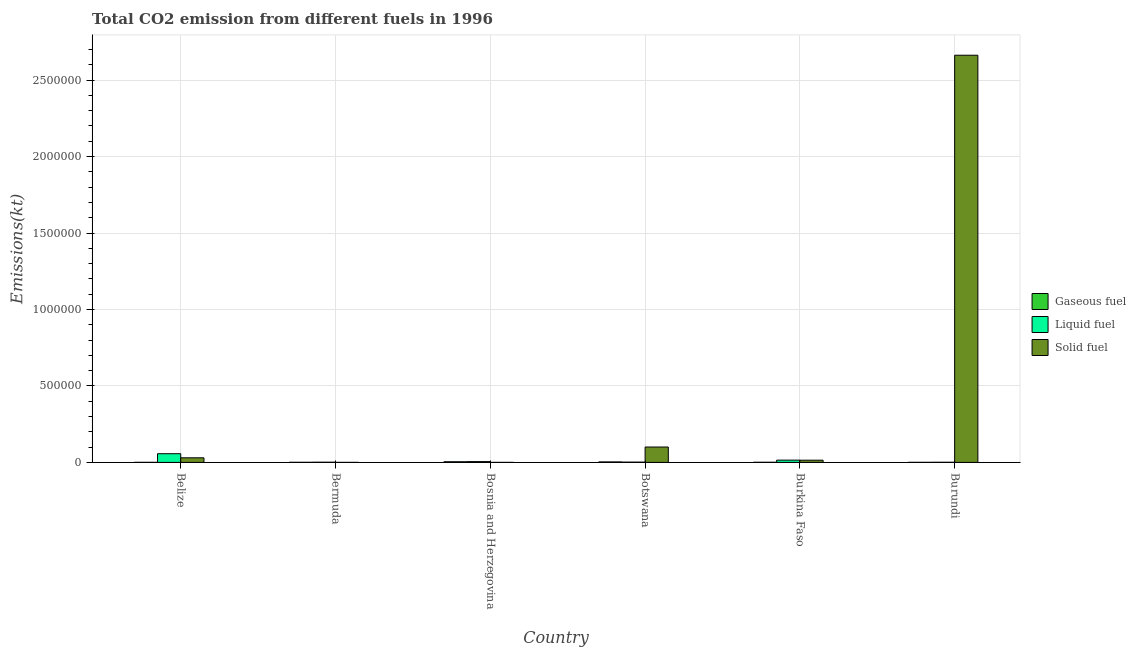How many different coloured bars are there?
Your response must be concise. 3. How many groups of bars are there?
Offer a terse response. 6. Are the number of bars per tick equal to the number of legend labels?
Ensure brevity in your answer.  Yes. Are the number of bars on each tick of the X-axis equal?
Make the answer very short. Yes. What is the label of the 1st group of bars from the left?
Your answer should be compact. Belize. What is the amount of co2 emissions from solid fuel in Belize?
Provide a short and direct response. 3.00e+04. Across all countries, what is the maximum amount of co2 emissions from gaseous fuel?
Provide a short and direct response. 4257.39. Across all countries, what is the minimum amount of co2 emissions from solid fuel?
Provide a succinct answer. 3.67. In which country was the amount of co2 emissions from liquid fuel maximum?
Offer a terse response. Belize. In which country was the amount of co2 emissions from liquid fuel minimum?
Make the answer very short. Burundi. What is the total amount of co2 emissions from liquid fuel in the graph?
Make the answer very short. 8.03e+04. What is the difference between the amount of co2 emissions from liquid fuel in Bermuda and that in Bosnia and Herzegovina?
Your answer should be compact. -4151.04. What is the difference between the amount of co2 emissions from gaseous fuel in Burkina Faso and the amount of co2 emissions from liquid fuel in Botswana?
Ensure brevity in your answer.  -1001.09. What is the average amount of co2 emissions from solid fuel per country?
Ensure brevity in your answer.  4.68e+05. What is the difference between the amount of co2 emissions from liquid fuel and amount of co2 emissions from solid fuel in Burundi?
Keep it short and to the point. -2.66e+06. What is the ratio of the amount of co2 emissions from solid fuel in Bermuda to that in Botswana?
Your response must be concise. 0. Is the amount of co2 emissions from solid fuel in Bosnia and Herzegovina less than that in Botswana?
Provide a short and direct response. Yes. Is the difference between the amount of co2 emissions from gaseous fuel in Botswana and Burkina Faso greater than the difference between the amount of co2 emissions from liquid fuel in Botswana and Burkina Faso?
Offer a terse response. Yes. What is the difference between the highest and the second highest amount of co2 emissions from solid fuel?
Make the answer very short. 2.56e+06. What is the difference between the highest and the lowest amount of co2 emissions from solid fuel?
Offer a very short reply. 2.66e+06. In how many countries, is the amount of co2 emissions from gaseous fuel greater than the average amount of co2 emissions from gaseous fuel taken over all countries?
Keep it short and to the point. 2. Is the sum of the amount of co2 emissions from gaseous fuel in Burkina Faso and Burundi greater than the maximum amount of co2 emissions from liquid fuel across all countries?
Offer a terse response. No. What does the 1st bar from the left in Burkina Faso represents?
Give a very brief answer. Gaseous fuel. What does the 3rd bar from the right in Burkina Faso represents?
Make the answer very short. Gaseous fuel. How many bars are there?
Offer a very short reply. 18. What is the difference between two consecutive major ticks on the Y-axis?
Your response must be concise. 5.00e+05. Are the values on the major ticks of Y-axis written in scientific E-notation?
Ensure brevity in your answer.  No. Does the graph contain any zero values?
Give a very brief answer. No. Does the graph contain grids?
Offer a terse response. Yes. Where does the legend appear in the graph?
Your answer should be very brief. Center right. How are the legend labels stacked?
Offer a very short reply. Vertical. What is the title of the graph?
Make the answer very short. Total CO2 emission from different fuels in 1996. Does "Tertiary" appear as one of the legend labels in the graph?
Your answer should be very brief. No. What is the label or title of the X-axis?
Offer a terse response. Country. What is the label or title of the Y-axis?
Offer a terse response. Emissions(kt). What is the Emissions(kt) of Gaseous fuel in Belize?
Your response must be concise. 308.03. What is the Emissions(kt) in Liquid fuel in Belize?
Your response must be concise. 5.68e+04. What is the Emissions(kt) in Solid fuel in Belize?
Provide a succinct answer. 3.00e+04. What is the Emissions(kt) in Gaseous fuel in Bermuda?
Keep it short and to the point. 476.71. What is the Emissions(kt) of Liquid fuel in Bermuda?
Your response must be concise. 1085.43. What is the Emissions(kt) of Solid fuel in Bermuda?
Your answer should be very brief. 18.34. What is the Emissions(kt) in Gaseous fuel in Bosnia and Herzegovina?
Your answer should be compact. 4257.39. What is the Emissions(kt) of Liquid fuel in Bosnia and Herzegovina?
Give a very brief answer. 5236.48. What is the Emissions(kt) in Solid fuel in Bosnia and Herzegovina?
Offer a terse response. 3.67. What is the Emissions(kt) in Gaseous fuel in Botswana?
Offer a very short reply. 3138.95. What is the Emissions(kt) in Liquid fuel in Botswana?
Provide a succinct answer. 1708.82. What is the Emissions(kt) in Solid fuel in Botswana?
Provide a short and direct response. 1.00e+05. What is the Emissions(kt) of Gaseous fuel in Burkina Faso?
Your answer should be compact. 707.73. What is the Emissions(kt) of Liquid fuel in Burkina Faso?
Keep it short and to the point. 1.48e+04. What is the Emissions(kt) of Solid fuel in Burkina Faso?
Make the answer very short. 1.44e+04. What is the Emissions(kt) of Gaseous fuel in Burundi?
Keep it short and to the point. 319.03. What is the Emissions(kt) in Liquid fuel in Burundi?
Ensure brevity in your answer.  693.06. What is the Emissions(kt) in Solid fuel in Burundi?
Your answer should be compact. 2.66e+06. Across all countries, what is the maximum Emissions(kt) of Gaseous fuel?
Your answer should be compact. 4257.39. Across all countries, what is the maximum Emissions(kt) of Liquid fuel?
Keep it short and to the point. 5.68e+04. Across all countries, what is the maximum Emissions(kt) of Solid fuel?
Your response must be concise. 2.66e+06. Across all countries, what is the minimum Emissions(kt) in Gaseous fuel?
Make the answer very short. 308.03. Across all countries, what is the minimum Emissions(kt) of Liquid fuel?
Offer a very short reply. 693.06. Across all countries, what is the minimum Emissions(kt) in Solid fuel?
Keep it short and to the point. 3.67. What is the total Emissions(kt) in Gaseous fuel in the graph?
Your answer should be very brief. 9207.84. What is the total Emissions(kt) in Liquid fuel in the graph?
Offer a terse response. 8.03e+04. What is the total Emissions(kt) of Solid fuel in the graph?
Your answer should be compact. 2.81e+06. What is the difference between the Emissions(kt) of Gaseous fuel in Belize and that in Bermuda?
Your response must be concise. -168.68. What is the difference between the Emissions(kt) in Liquid fuel in Belize and that in Bermuda?
Give a very brief answer. 5.57e+04. What is the difference between the Emissions(kt) in Solid fuel in Belize and that in Bermuda?
Your answer should be compact. 3.00e+04. What is the difference between the Emissions(kt) in Gaseous fuel in Belize and that in Bosnia and Herzegovina?
Give a very brief answer. -3949.36. What is the difference between the Emissions(kt) of Liquid fuel in Belize and that in Bosnia and Herzegovina?
Offer a terse response. 5.15e+04. What is the difference between the Emissions(kt) of Solid fuel in Belize and that in Bosnia and Herzegovina?
Offer a very short reply. 3.00e+04. What is the difference between the Emissions(kt) of Gaseous fuel in Belize and that in Botswana?
Your answer should be compact. -2830.92. What is the difference between the Emissions(kt) in Liquid fuel in Belize and that in Botswana?
Your answer should be very brief. 5.51e+04. What is the difference between the Emissions(kt) in Solid fuel in Belize and that in Botswana?
Give a very brief answer. -7.05e+04. What is the difference between the Emissions(kt) of Gaseous fuel in Belize and that in Burkina Faso?
Ensure brevity in your answer.  -399.7. What is the difference between the Emissions(kt) of Liquid fuel in Belize and that in Burkina Faso?
Offer a terse response. 4.20e+04. What is the difference between the Emissions(kt) of Solid fuel in Belize and that in Burkina Faso?
Give a very brief answer. 1.56e+04. What is the difference between the Emissions(kt) of Gaseous fuel in Belize and that in Burundi?
Your response must be concise. -11. What is the difference between the Emissions(kt) in Liquid fuel in Belize and that in Burundi?
Provide a succinct answer. 5.61e+04. What is the difference between the Emissions(kt) in Solid fuel in Belize and that in Burundi?
Offer a terse response. -2.63e+06. What is the difference between the Emissions(kt) in Gaseous fuel in Bermuda and that in Bosnia and Herzegovina?
Ensure brevity in your answer.  -3780.68. What is the difference between the Emissions(kt) of Liquid fuel in Bermuda and that in Bosnia and Herzegovina?
Your answer should be compact. -4151.04. What is the difference between the Emissions(kt) in Solid fuel in Bermuda and that in Bosnia and Herzegovina?
Make the answer very short. 14.67. What is the difference between the Emissions(kt) in Gaseous fuel in Bermuda and that in Botswana?
Keep it short and to the point. -2662.24. What is the difference between the Emissions(kt) of Liquid fuel in Bermuda and that in Botswana?
Offer a terse response. -623.39. What is the difference between the Emissions(kt) of Solid fuel in Bermuda and that in Botswana?
Keep it short and to the point. -1.00e+05. What is the difference between the Emissions(kt) in Gaseous fuel in Bermuda and that in Burkina Faso?
Give a very brief answer. -231.02. What is the difference between the Emissions(kt) of Liquid fuel in Bermuda and that in Burkina Faso?
Provide a short and direct response. -1.37e+04. What is the difference between the Emissions(kt) of Solid fuel in Bermuda and that in Burkina Faso?
Provide a succinct answer. -1.44e+04. What is the difference between the Emissions(kt) of Gaseous fuel in Bermuda and that in Burundi?
Provide a short and direct response. 157.68. What is the difference between the Emissions(kt) in Liquid fuel in Bermuda and that in Burundi?
Ensure brevity in your answer.  392.37. What is the difference between the Emissions(kt) of Solid fuel in Bermuda and that in Burundi?
Give a very brief answer. -2.66e+06. What is the difference between the Emissions(kt) of Gaseous fuel in Bosnia and Herzegovina and that in Botswana?
Your response must be concise. 1118.43. What is the difference between the Emissions(kt) of Liquid fuel in Bosnia and Herzegovina and that in Botswana?
Your response must be concise. 3527.65. What is the difference between the Emissions(kt) of Solid fuel in Bosnia and Herzegovina and that in Botswana?
Your answer should be compact. -1.00e+05. What is the difference between the Emissions(kt) of Gaseous fuel in Bosnia and Herzegovina and that in Burkina Faso?
Your answer should be compact. 3549.66. What is the difference between the Emissions(kt) in Liquid fuel in Bosnia and Herzegovina and that in Burkina Faso?
Offer a very short reply. -9537.87. What is the difference between the Emissions(kt) of Solid fuel in Bosnia and Herzegovina and that in Burkina Faso?
Your answer should be compact. -1.44e+04. What is the difference between the Emissions(kt) of Gaseous fuel in Bosnia and Herzegovina and that in Burundi?
Offer a terse response. 3938.36. What is the difference between the Emissions(kt) in Liquid fuel in Bosnia and Herzegovina and that in Burundi?
Offer a very short reply. 4543.41. What is the difference between the Emissions(kt) of Solid fuel in Bosnia and Herzegovina and that in Burundi?
Provide a short and direct response. -2.66e+06. What is the difference between the Emissions(kt) in Gaseous fuel in Botswana and that in Burkina Faso?
Make the answer very short. 2431.22. What is the difference between the Emissions(kt) in Liquid fuel in Botswana and that in Burkina Faso?
Ensure brevity in your answer.  -1.31e+04. What is the difference between the Emissions(kt) of Solid fuel in Botswana and that in Burkina Faso?
Your response must be concise. 8.61e+04. What is the difference between the Emissions(kt) in Gaseous fuel in Botswana and that in Burundi?
Offer a terse response. 2819.92. What is the difference between the Emissions(kt) of Liquid fuel in Botswana and that in Burundi?
Your answer should be compact. 1015.76. What is the difference between the Emissions(kt) in Solid fuel in Botswana and that in Burundi?
Your answer should be compact. -2.56e+06. What is the difference between the Emissions(kt) in Gaseous fuel in Burkina Faso and that in Burundi?
Offer a very short reply. 388.7. What is the difference between the Emissions(kt) of Liquid fuel in Burkina Faso and that in Burundi?
Keep it short and to the point. 1.41e+04. What is the difference between the Emissions(kt) in Solid fuel in Burkina Faso and that in Burundi?
Your answer should be very brief. -2.65e+06. What is the difference between the Emissions(kt) of Gaseous fuel in Belize and the Emissions(kt) of Liquid fuel in Bermuda?
Offer a very short reply. -777.4. What is the difference between the Emissions(kt) in Gaseous fuel in Belize and the Emissions(kt) in Solid fuel in Bermuda?
Your answer should be very brief. 289.69. What is the difference between the Emissions(kt) of Liquid fuel in Belize and the Emissions(kt) of Solid fuel in Bermuda?
Make the answer very short. 5.68e+04. What is the difference between the Emissions(kt) of Gaseous fuel in Belize and the Emissions(kt) of Liquid fuel in Bosnia and Herzegovina?
Ensure brevity in your answer.  -4928.45. What is the difference between the Emissions(kt) of Gaseous fuel in Belize and the Emissions(kt) of Solid fuel in Bosnia and Herzegovina?
Provide a succinct answer. 304.36. What is the difference between the Emissions(kt) of Liquid fuel in Belize and the Emissions(kt) of Solid fuel in Bosnia and Herzegovina?
Ensure brevity in your answer.  5.68e+04. What is the difference between the Emissions(kt) of Gaseous fuel in Belize and the Emissions(kt) of Liquid fuel in Botswana?
Provide a succinct answer. -1400.79. What is the difference between the Emissions(kt) in Gaseous fuel in Belize and the Emissions(kt) in Solid fuel in Botswana?
Make the answer very short. -1.00e+05. What is the difference between the Emissions(kt) of Liquid fuel in Belize and the Emissions(kt) of Solid fuel in Botswana?
Your response must be concise. -4.37e+04. What is the difference between the Emissions(kt) in Gaseous fuel in Belize and the Emissions(kt) in Liquid fuel in Burkina Faso?
Your answer should be compact. -1.45e+04. What is the difference between the Emissions(kt) in Gaseous fuel in Belize and the Emissions(kt) in Solid fuel in Burkina Faso?
Make the answer very short. -1.41e+04. What is the difference between the Emissions(kt) of Liquid fuel in Belize and the Emissions(kt) of Solid fuel in Burkina Faso?
Offer a very short reply. 4.24e+04. What is the difference between the Emissions(kt) of Gaseous fuel in Belize and the Emissions(kt) of Liquid fuel in Burundi?
Give a very brief answer. -385.04. What is the difference between the Emissions(kt) in Gaseous fuel in Belize and the Emissions(kt) in Solid fuel in Burundi?
Your answer should be very brief. -2.66e+06. What is the difference between the Emissions(kt) in Liquid fuel in Belize and the Emissions(kt) in Solid fuel in Burundi?
Offer a very short reply. -2.61e+06. What is the difference between the Emissions(kt) of Gaseous fuel in Bermuda and the Emissions(kt) of Liquid fuel in Bosnia and Herzegovina?
Give a very brief answer. -4759.77. What is the difference between the Emissions(kt) of Gaseous fuel in Bermuda and the Emissions(kt) of Solid fuel in Bosnia and Herzegovina?
Make the answer very short. 473.04. What is the difference between the Emissions(kt) of Liquid fuel in Bermuda and the Emissions(kt) of Solid fuel in Bosnia and Herzegovina?
Keep it short and to the point. 1081.77. What is the difference between the Emissions(kt) of Gaseous fuel in Bermuda and the Emissions(kt) of Liquid fuel in Botswana?
Keep it short and to the point. -1232.11. What is the difference between the Emissions(kt) of Gaseous fuel in Bermuda and the Emissions(kt) of Solid fuel in Botswana?
Your answer should be compact. -1.00e+05. What is the difference between the Emissions(kt) in Liquid fuel in Bermuda and the Emissions(kt) in Solid fuel in Botswana?
Your answer should be very brief. -9.94e+04. What is the difference between the Emissions(kt) of Gaseous fuel in Bermuda and the Emissions(kt) of Liquid fuel in Burkina Faso?
Offer a terse response. -1.43e+04. What is the difference between the Emissions(kt) of Gaseous fuel in Bermuda and the Emissions(kt) of Solid fuel in Burkina Faso?
Your answer should be very brief. -1.39e+04. What is the difference between the Emissions(kt) of Liquid fuel in Bermuda and the Emissions(kt) of Solid fuel in Burkina Faso?
Ensure brevity in your answer.  -1.33e+04. What is the difference between the Emissions(kt) of Gaseous fuel in Bermuda and the Emissions(kt) of Liquid fuel in Burundi?
Your response must be concise. -216.35. What is the difference between the Emissions(kt) in Gaseous fuel in Bermuda and the Emissions(kt) in Solid fuel in Burundi?
Ensure brevity in your answer.  -2.66e+06. What is the difference between the Emissions(kt) of Liquid fuel in Bermuda and the Emissions(kt) of Solid fuel in Burundi?
Give a very brief answer. -2.66e+06. What is the difference between the Emissions(kt) of Gaseous fuel in Bosnia and Herzegovina and the Emissions(kt) of Liquid fuel in Botswana?
Your response must be concise. 2548.57. What is the difference between the Emissions(kt) in Gaseous fuel in Bosnia and Herzegovina and the Emissions(kt) in Solid fuel in Botswana?
Keep it short and to the point. -9.62e+04. What is the difference between the Emissions(kt) of Liquid fuel in Bosnia and Herzegovina and the Emissions(kt) of Solid fuel in Botswana?
Provide a short and direct response. -9.53e+04. What is the difference between the Emissions(kt) in Gaseous fuel in Bosnia and Herzegovina and the Emissions(kt) in Liquid fuel in Burkina Faso?
Your answer should be compact. -1.05e+04. What is the difference between the Emissions(kt) in Gaseous fuel in Bosnia and Herzegovina and the Emissions(kt) in Solid fuel in Burkina Faso?
Give a very brief answer. -1.02e+04. What is the difference between the Emissions(kt) of Liquid fuel in Bosnia and Herzegovina and the Emissions(kt) of Solid fuel in Burkina Faso?
Make the answer very short. -9189.5. What is the difference between the Emissions(kt) of Gaseous fuel in Bosnia and Herzegovina and the Emissions(kt) of Liquid fuel in Burundi?
Offer a terse response. 3564.32. What is the difference between the Emissions(kt) of Gaseous fuel in Bosnia and Herzegovina and the Emissions(kt) of Solid fuel in Burundi?
Offer a terse response. -2.66e+06. What is the difference between the Emissions(kt) of Liquid fuel in Bosnia and Herzegovina and the Emissions(kt) of Solid fuel in Burundi?
Make the answer very short. -2.66e+06. What is the difference between the Emissions(kt) in Gaseous fuel in Botswana and the Emissions(kt) in Liquid fuel in Burkina Faso?
Provide a short and direct response. -1.16e+04. What is the difference between the Emissions(kt) in Gaseous fuel in Botswana and the Emissions(kt) in Solid fuel in Burkina Faso?
Offer a very short reply. -1.13e+04. What is the difference between the Emissions(kt) of Liquid fuel in Botswana and the Emissions(kt) of Solid fuel in Burkina Faso?
Provide a succinct answer. -1.27e+04. What is the difference between the Emissions(kt) of Gaseous fuel in Botswana and the Emissions(kt) of Liquid fuel in Burundi?
Offer a terse response. 2445.89. What is the difference between the Emissions(kt) of Gaseous fuel in Botswana and the Emissions(kt) of Solid fuel in Burundi?
Offer a very short reply. -2.66e+06. What is the difference between the Emissions(kt) of Liquid fuel in Botswana and the Emissions(kt) of Solid fuel in Burundi?
Keep it short and to the point. -2.66e+06. What is the difference between the Emissions(kt) of Gaseous fuel in Burkina Faso and the Emissions(kt) of Liquid fuel in Burundi?
Make the answer very short. 14.67. What is the difference between the Emissions(kt) of Gaseous fuel in Burkina Faso and the Emissions(kt) of Solid fuel in Burundi?
Give a very brief answer. -2.66e+06. What is the difference between the Emissions(kt) in Liquid fuel in Burkina Faso and the Emissions(kt) in Solid fuel in Burundi?
Provide a succinct answer. -2.65e+06. What is the average Emissions(kt) of Gaseous fuel per country?
Keep it short and to the point. 1534.64. What is the average Emissions(kt) in Liquid fuel per country?
Offer a terse response. 1.34e+04. What is the average Emissions(kt) in Solid fuel per country?
Give a very brief answer. 4.68e+05. What is the difference between the Emissions(kt) in Gaseous fuel and Emissions(kt) in Liquid fuel in Belize?
Ensure brevity in your answer.  -5.65e+04. What is the difference between the Emissions(kt) of Gaseous fuel and Emissions(kt) of Solid fuel in Belize?
Provide a short and direct response. -2.97e+04. What is the difference between the Emissions(kt) of Liquid fuel and Emissions(kt) of Solid fuel in Belize?
Your answer should be compact. 2.68e+04. What is the difference between the Emissions(kt) in Gaseous fuel and Emissions(kt) in Liquid fuel in Bermuda?
Offer a terse response. -608.72. What is the difference between the Emissions(kt) in Gaseous fuel and Emissions(kt) in Solid fuel in Bermuda?
Provide a short and direct response. 458.38. What is the difference between the Emissions(kt) in Liquid fuel and Emissions(kt) in Solid fuel in Bermuda?
Your response must be concise. 1067.1. What is the difference between the Emissions(kt) of Gaseous fuel and Emissions(kt) of Liquid fuel in Bosnia and Herzegovina?
Your answer should be very brief. -979.09. What is the difference between the Emissions(kt) of Gaseous fuel and Emissions(kt) of Solid fuel in Bosnia and Herzegovina?
Make the answer very short. 4253.72. What is the difference between the Emissions(kt) in Liquid fuel and Emissions(kt) in Solid fuel in Bosnia and Herzegovina?
Your answer should be compact. 5232.81. What is the difference between the Emissions(kt) of Gaseous fuel and Emissions(kt) of Liquid fuel in Botswana?
Provide a short and direct response. 1430.13. What is the difference between the Emissions(kt) in Gaseous fuel and Emissions(kt) in Solid fuel in Botswana?
Provide a succinct answer. -9.74e+04. What is the difference between the Emissions(kt) in Liquid fuel and Emissions(kt) in Solid fuel in Botswana?
Your answer should be compact. -9.88e+04. What is the difference between the Emissions(kt) in Gaseous fuel and Emissions(kt) in Liquid fuel in Burkina Faso?
Your answer should be very brief. -1.41e+04. What is the difference between the Emissions(kt) of Gaseous fuel and Emissions(kt) of Solid fuel in Burkina Faso?
Provide a short and direct response. -1.37e+04. What is the difference between the Emissions(kt) in Liquid fuel and Emissions(kt) in Solid fuel in Burkina Faso?
Your answer should be very brief. 348.37. What is the difference between the Emissions(kt) in Gaseous fuel and Emissions(kt) in Liquid fuel in Burundi?
Your answer should be very brief. -374.03. What is the difference between the Emissions(kt) of Gaseous fuel and Emissions(kt) of Solid fuel in Burundi?
Make the answer very short. -2.66e+06. What is the difference between the Emissions(kt) in Liquid fuel and Emissions(kt) in Solid fuel in Burundi?
Give a very brief answer. -2.66e+06. What is the ratio of the Emissions(kt) of Gaseous fuel in Belize to that in Bermuda?
Provide a succinct answer. 0.65. What is the ratio of the Emissions(kt) in Liquid fuel in Belize to that in Bermuda?
Offer a very short reply. 52.31. What is the ratio of the Emissions(kt) of Solid fuel in Belize to that in Bermuda?
Your answer should be compact. 1636.6. What is the ratio of the Emissions(kt) of Gaseous fuel in Belize to that in Bosnia and Herzegovina?
Provide a short and direct response. 0.07. What is the ratio of the Emissions(kt) in Liquid fuel in Belize to that in Bosnia and Herzegovina?
Keep it short and to the point. 10.84. What is the ratio of the Emissions(kt) in Solid fuel in Belize to that in Bosnia and Herzegovina?
Provide a succinct answer. 8183. What is the ratio of the Emissions(kt) in Gaseous fuel in Belize to that in Botswana?
Your response must be concise. 0.1. What is the ratio of the Emissions(kt) in Liquid fuel in Belize to that in Botswana?
Ensure brevity in your answer.  33.23. What is the ratio of the Emissions(kt) in Solid fuel in Belize to that in Botswana?
Provide a short and direct response. 0.3. What is the ratio of the Emissions(kt) of Gaseous fuel in Belize to that in Burkina Faso?
Make the answer very short. 0.44. What is the ratio of the Emissions(kt) in Liquid fuel in Belize to that in Burkina Faso?
Your response must be concise. 3.84. What is the ratio of the Emissions(kt) of Solid fuel in Belize to that in Burkina Faso?
Provide a succinct answer. 2.08. What is the ratio of the Emissions(kt) in Gaseous fuel in Belize to that in Burundi?
Offer a terse response. 0.97. What is the ratio of the Emissions(kt) of Liquid fuel in Belize to that in Burundi?
Your response must be concise. 81.93. What is the ratio of the Emissions(kt) in Solid fuel in Belize to that in Burundi?
Provide a succinct answer. 0.01. What is the ratio of the Emissions(kt) of Gaseous fuel in Bermuda to that in Bosnia and Herzegovina?
Provide a succinct answer. 0.11. What is the ratio of the Emissions(kt) of Liquid fuel in Bermuda to that in Bosnia and Herzegovina?
Offer a very short reply. 0.21. What is the ratio of the Emissions(kt) in Gaseous fuel in Bermuda to that in Botswana?
Provide a succinct answer. 0.15. What is the ratio of the Emissions(kt) of Liquid fuel in Bermuda to that in Botswana?
Your answer should be compact. 0.64. What is the ratio of the Emissions(kt) of Gaseous fuel in Bermuda to that in Burkina Faso?
Provide a short and direct response. 0.67. What is the ratio of the Emissions(kt) of Liquid fuel in Bermuda to that in Burkina Faso?
Make the answer very short. 0.07. What is the ratio of the Emissions(kt) in Solid fuel in Bermuda to that in Burkina Faso?
Your response must be concise. 0. What is the ratio of the Emissions(kt) in Gaseous fuel in Bermuda to that in Burundi?
Your answer should be very brief. 1.49. What is the ratio of the Emissions(kt) in Liquid fuel in Bermuda to that in Burundi?
Provide a succinct answer. 1.57. What is the ratio of the Emissions(kt) in Solid fuel in Bermuda to that in Burundi?
Provide a short and direct response. 0. What is the ratio of the Emissions(kt) in Gaseous fuel in Bosnia and Herzegovina to that in Botswana?
Make the answer very short. 1.36. What is the ratio of the Emissions(kt) of Liquid fuel in Bosnia and Herzegovina to that in Botswana?
Make the answer very short. 3.06. What is the ratio of the Emissions(kt) in Solid fuel in Bosnia and Herzegovina to that in Botswana?
Offer a terse response. 0. What is the ratio of the Emissions(kt) of Gaseous fuel in Bosnia and Herzegovina to that in Burkina Faso?
Provide a succinct answer. 6.02. What is the ratio of the Emissions(kt) of Liquid fuel in Bosnia and Herzegovina to that in Burkina Faso?
Ensure brevity in your answer.  0.35. What is the ratio of the Emissions(kt) of Gaseous fuel in Bosnia and Herzegovina to that in Burundi?
Your answer should be compact. 13.34. What is the ratio of the Emissions(kt) of Liquid fuel in Bosnia and Herzegovina to that in Burundi?
Provide a succinct answer. 7.56. What is the ratio of the Emissions(kt) of Solid fuel in Bosnia and Herzegovina to that in Burundi?
Ensure brevity in your answer.  0. What is the ratio of the Emissions(kt) in Gaseous fuel in Botswana to that in Burkina Faso?
Ensure brevity in your answer.  4.44. What is the ratio of the Emissions(kt) in Liquid fuel in Botswana to that in Burkina Faso?
Ensure brevity in your answer.  0.12. What is the ratio of the Emissions(kt) of Solid fuel in Botswana to that in Burkina Faso?
Your answer should be very brief. 6.97. What is the ratio of the Emissions(kt) of Gaseous fuel in Botswana to that in Burundi?
Ensure brevity in your answer.  9.84. What is the ratio of the Emissions(kt) in Liquid fuel in Botswana to that in Burundi?
Give a very brief answer. 2.47. What is the ratio of the Emissions(kt) of Solid fuel in Botswana to that in Burundi?
Provide a succinct answer. 0.04. What is the ratio of the Emissions(kt) of Gaseous fuel in Burkina Faso to that in Burundi?
Ensure brevity in your answer.  2.22. What is the ratio of the Emissions(kt) in Liquid fuel in Burkina Faso to that in Burundi?
Your answer should be very brief. 21.32. What is the ratio of the Emissions(kt) in Solid fuel in Burkina Faso to that in Burundi?
Offer a terse response. 0.01. What is the difference between the highest and the second highest Emissions(kt) of Gaseous fuel?
Your answer should be compact. 1118.43. What is the difference between the highest and the second highest Emissions(kt) in Liquid fuel?
Offer a very short reply. 4.20e+04. What is the difference between the highest and the second highest Emissions(kt) of Solid fuel?
Make the answer very short. 2.56e+06. What is the difference between the highest and the lowest Emissions(kt) of Gaseous fuel?
Make the answer very short. 3949.36. What is the difference between the highest and the lowest Emissions(kt) in Liquid fuel?
Your answer should be compact. 5.61e+04. What is the difference between the highest and the lowest Emissions(kt) in Solid fuel?
Give a very brief answer. 2.66e+06. 